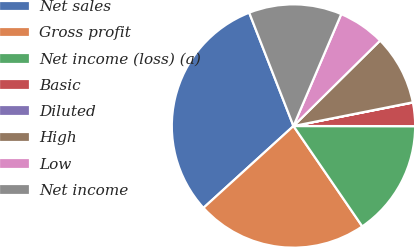<chart> <loc_0><loc_0><loc_500><loc_500><pie_chart><fcel>Net sales<fcel>Gross profit<fcel>Net income (loss) (a)<fcel>Basic<fcel>Diluted<fcel>High<fcel>Low<fcel>Net income<nl><fcel>30.82%<fcel>22.82%<fcel>15.42%<fcel>3.11%<fcel>0.03%<fcel>9.27%<fcel>6.19%<fcel>12.35%<nl></chart> 